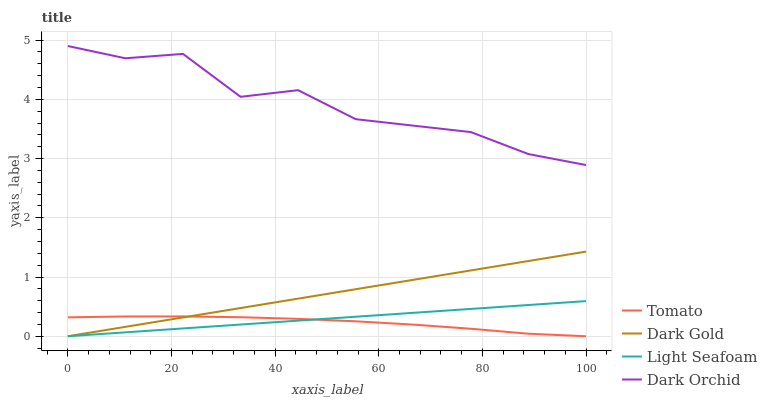Does Tomato have the minimum area under the curve?
Answer yes or no. Yes. Does Dark Orchid have the maximum area under the curve?
Answer yes or no. Yes. Does Light Seafoam have the minimum area under the curve?
Answer yes or no. No. Does Light Seafoam have the maximum area under the curve?
Answer yes or no. No. Is Light Seafoam the smoothest?
Answer yes or no. Yes. Is Dark Orchid the roughest?
Answer yes or no. Yes. Is Dark Orchid the smoothest?
Answer yes or no. No. Is Light Seafoam the roughest?
Answer yes or no. No. Does Dark Orchid have the lowest value?
Answer yes or no. No. Does Dark Orchid have the highest value?
Answer yes or no. Yes. Does Light Seafoam have the highest value?
Answer yes or no. No. Is Tomato less than Dark Orchid?
Answer yes or no. Yes. Is Dark Orchid greater than Light Seafoam?
Answer yes or no. Yes. Does Light Seafoam intersect Dark Gold?
Answer yes or no. Yes. Is Light Seafoam less than Dark Gold?
Answer yes or no. No. Is Light Seafoam greater than Dark Gold?
Answer yes or no. No. Does Tomato intersect Dark Orchid?
Answer yes or no. No. 